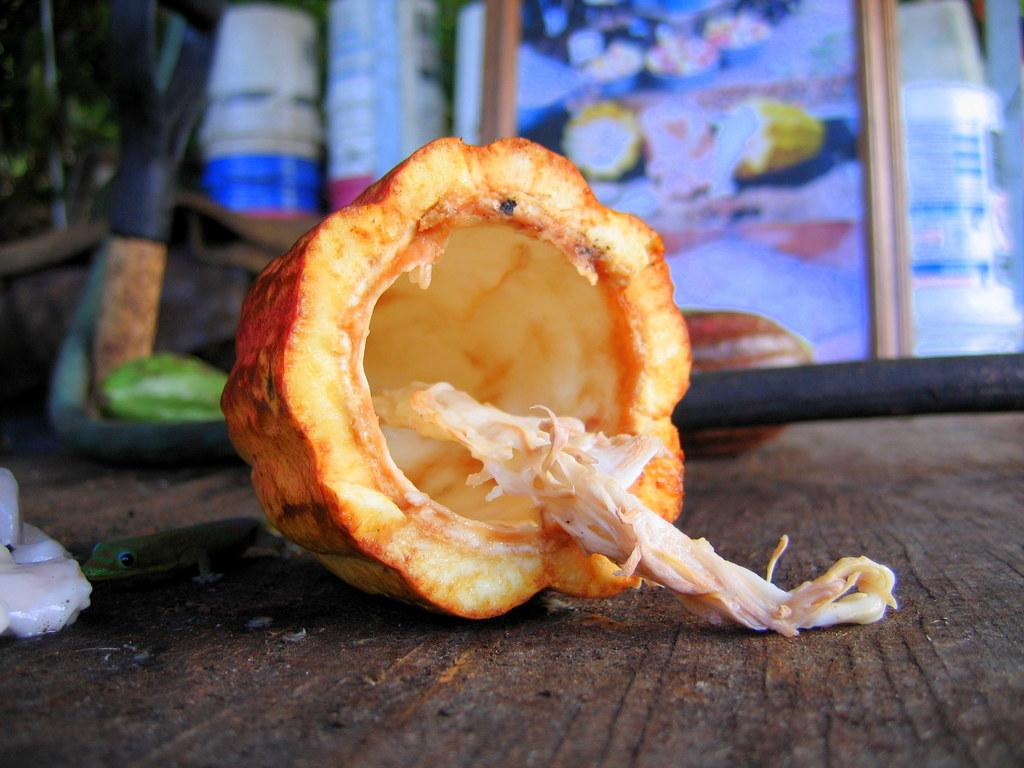What is the main subject of the image? There is a vegetable in the center of the image. Can you describe the background of the image? The background of the image is blurry. What type of hammer is being used to dig into the earth in the image? There is no hammer or digging activity present in the image; it features a vegetable with a blurry background. 